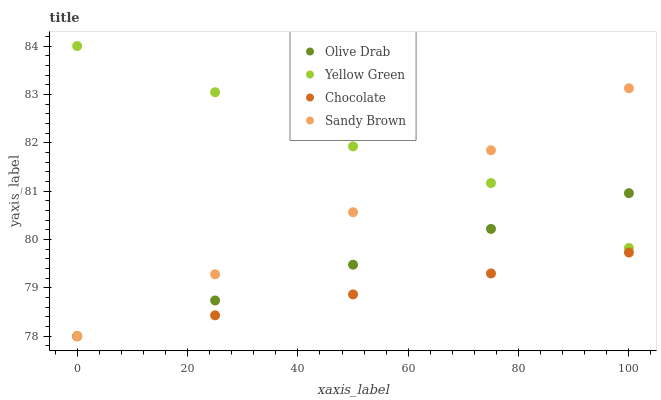Does Chocolate have the minimum area under the curve?
Answer yes or no. Yes. Does Yellow Green have the maximum area under the curve?
Answer yes or no. Yes. Does Olive Drab have the minimum area under the curve?
Answer yes or no. No. Does Olive Drab have the maximum area under the curve?
Answer yes or no. No. Is Sandy Brown the smoothest?
Answer yes or no. Yes. Is Yellow Green the roughest?
Answer yes or no. Yes. Is Olive Drab the smoothest?
Answer yes or no. No. Is Olive Drab the roughest?
Answer yes or no. No. Does Sandy Brown have the lowest value?
Answer yes or no. Yes. Does Yellow Green have the lowest value?
Answer yes or no. No. Does Yellow Green have the highest value?
Answer yes or no. Yes. Does Olive Drab have the highest value?
Answer yes or no. No. Is Chocolate less than Yellow Green?
Answer yes or no. Yes. Is Yellow Green greater than Chocolate?
Answer yes or no. Yes. Does Olive Drab intersect Chocolate?
Answer yes or no. Yes. Is Olive Drab less than Chocolate?
Answer yes or no. No. Is Olive Drab greater than Chocolate?
Answer yes or no. No. Does Chocolate intersect Yellow Green?
Answer yes or no. No. 